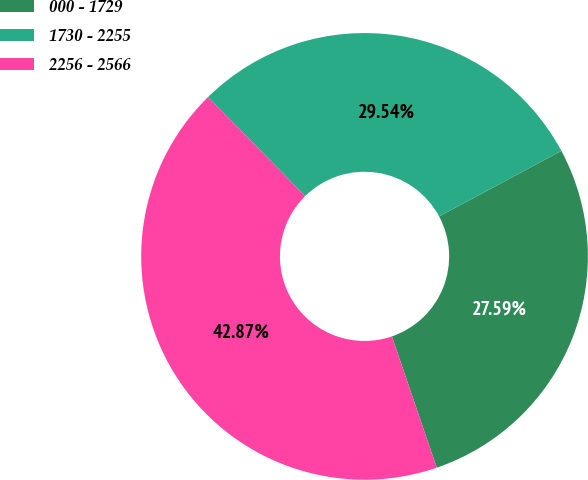Convert chart to OTSL. <chart><loc_0><loc_0><loc_500><loc_500><pie_chart><fcel>000 - 1729<fcel>1730 - 2255<fcel>2256 - 2566<nl><fcel>27.59%<fcel>29.54%<fcel>42.87%<nl></chart> 